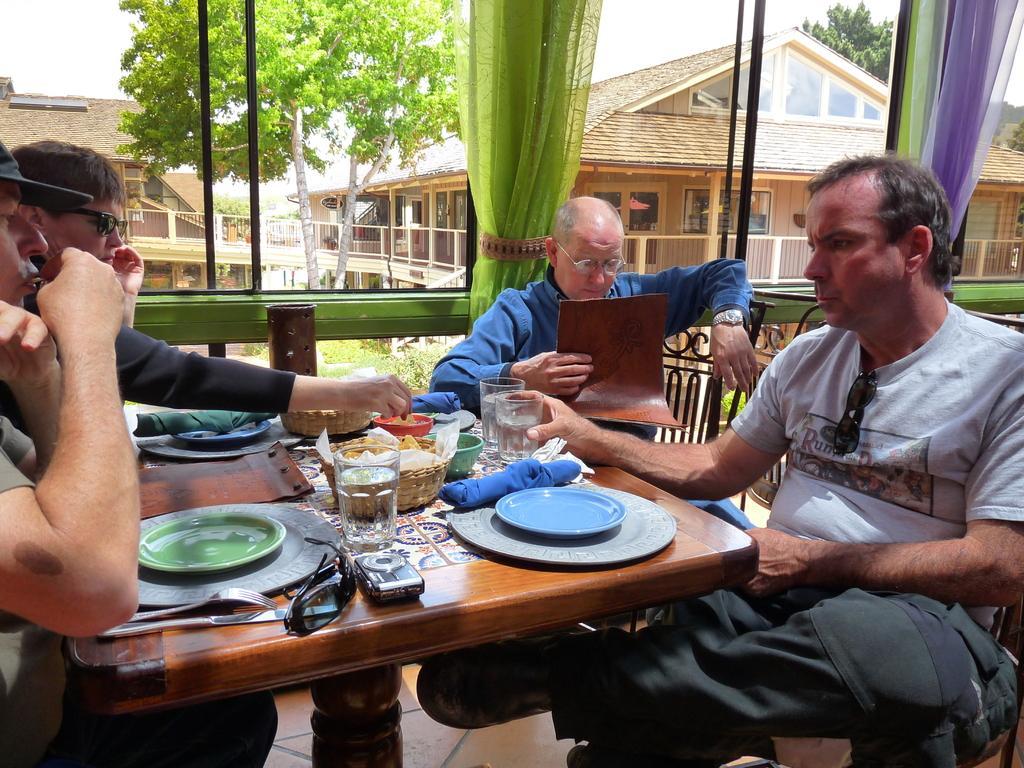Can you describe this image briefly? In the image I can see some people who are sitting around the table on which there are some things placed and also I can see a glass mirror from which I can see some buildings and trees. 